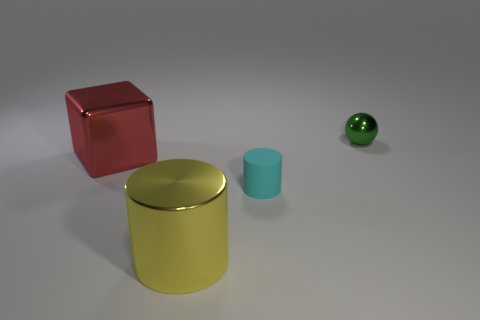Add 1 red matte things. How many objects exist? 5 Subtract all cubes. How many objects are left? 3 Subtract 0 red cylinders. How many objects are left? 4 Subtract all large red things. Subtract all red blocks. How many objects are left? 2 Add 3 big metallic cylinders. How many big metallic cylinders are left? 4 Add 1 large blue shiny cylinders. How many large blue shiny cylinders exist? 1 